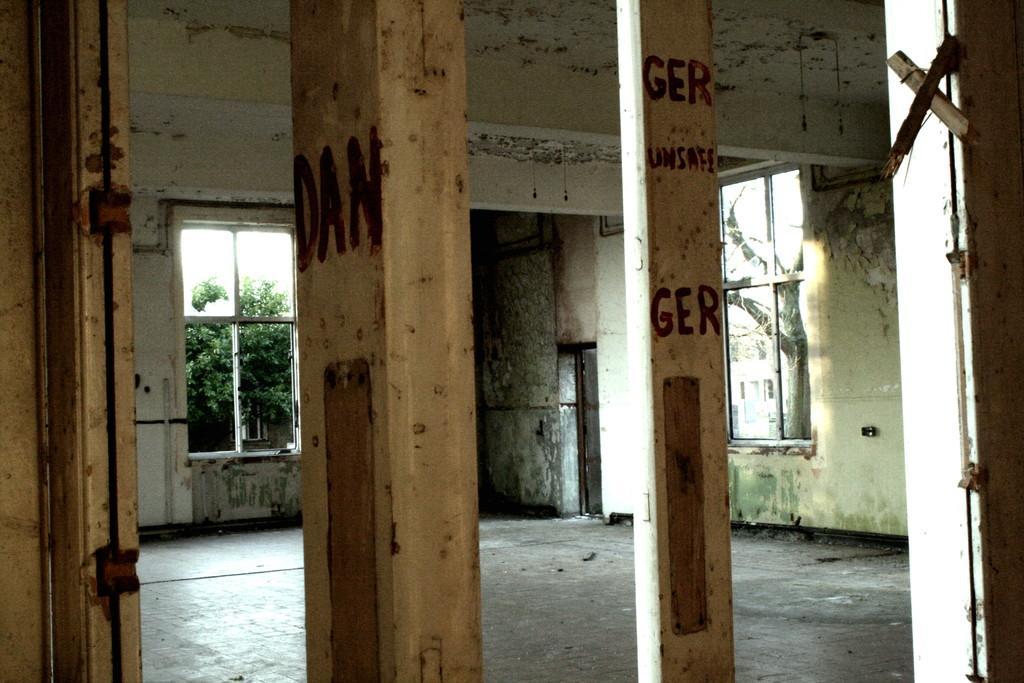In one or two sentences, can you explain what this image depicts? In this picture I can observe two pillars. I can observe windows on either sides of the picture. In the background there are trees. 